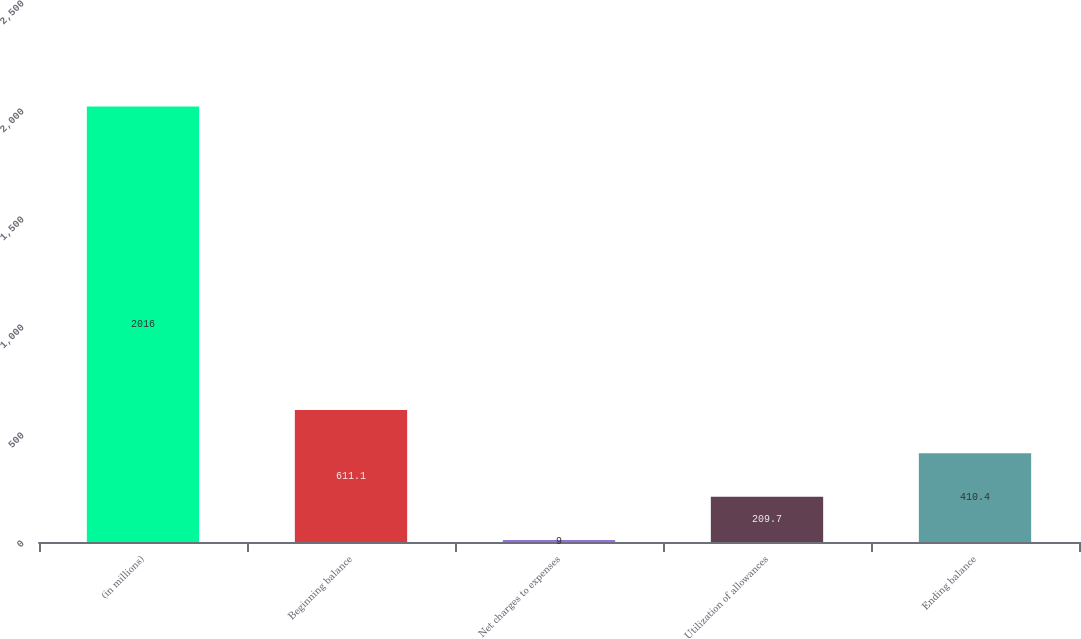Convert chart to OTSL. <chart><loc_0><loc_0><loc_500><loc_500><bar_chart><fcel>(in millions)<fcel>Beginning balance<fcel>Net charges to expenses<fcel>Utilization of allowances<fcel>Ending balance<nl><fcel>2016<fcel>611.1<fcel>9<fcel>209.7<fcel>410.4<nl></chart> 